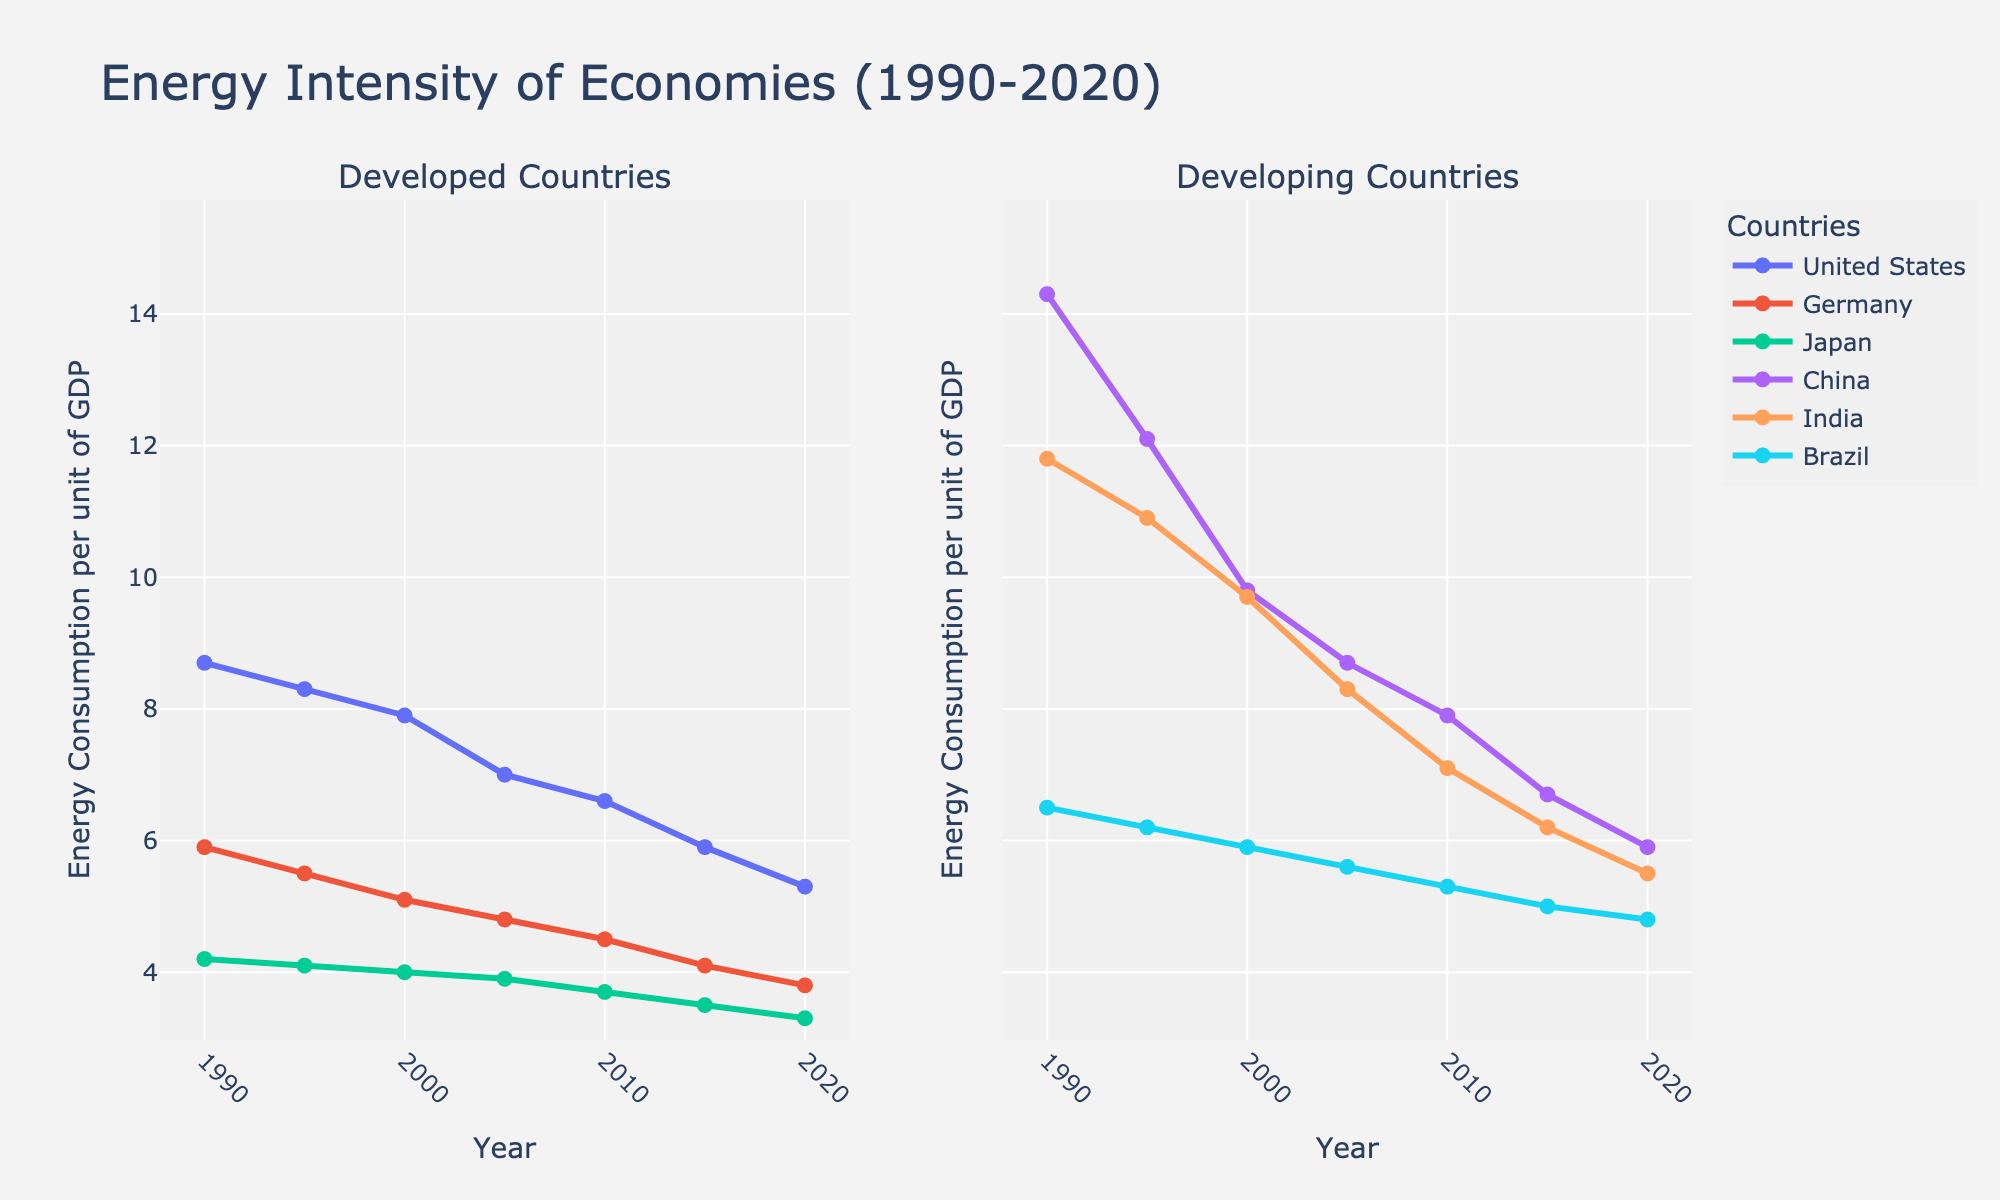What is the general trend of energy intensity in developed countries from 1990 to 2020? The energy intensity in developed countries (United States, Germany, and Japan) shows a decreasing trend from 1990 to 2020, indicating improved energy efficiency over time.
Answer: Decreasing Which developed country had the highest energy intensity in 1990 and by how much was it higher than the country with the lowest energy intensity in the same year? In 1990, the United States had the highest energy intensity among developed countries (8.7), while Japan had the lowest (4.2). The difference is 8.7 - 4.2 = 4.5.
Answer: United States, 4.5 By how much did China's energy intensity decrease from 1990 to 2020? China's energy intensity in 1990 was 14.3 and in 2020 was 5.9. The decrease is 14.3 - 5.9 = 8.4.
Answer: 8.4 Which developing country had the smallest reduction in energy intensity from 1990 to 2020? Brazil had a decrease from 6.5 in 1990 to 4.8 in 2020, which is 6.5 - 4.8 = 1.7, the smallest decrease among the developing countries.
Answer: Brazil How did the energy intensity of India compare to that of Germany in the year 2020? In 2020, India's energy intensity was 5.5 and Germany's was 3.8. India had a higher energy intensity by 5.5 - 3.8 = 1.7.
Answer: Higher by 1.7 What is the average energy intensity for Japan from 1990 to 2020? The average is calculated by summing the energy intensities for Japan (4.2 + 4.1 + 4.0 + 3.9 + 3.7 + 3.5 + 3.3) and then dividing by the number of years: (4.2 + 4.1 + 4.0 + 3.9 + 3.7 + 3.5 + 3.3) / 7 = 3.81.
Answer: 3.81 In which year did the United States see the largest drop in energy intensity compared to the previous recorded year? Comparing the falls: 1990-1995: 0.4, 1995-2000: 0.4, 2000-2005: 0.9, 2005-2010: 0.4, 2010-2015: 0.7, 2015-2020: 0.6. The largest drop is from 2000 to 2005 (0.9).
Answer: 2000-2005 From the graph, what can be inferred about the energy efficiency improvement in developing countries compared to developed countries between 1990 to 2020? Developing countries (China, India, Brazil) show a significant reduction in energy intensity, indicating notable improvements in energy efficiency. However, developed countries also improved steadily, suggesting ongoing efforts in energy efficiency.
Answer: Significant reduction in both Which country shows the most consistent decrease in energy intensity over the years? Germany exhibits a consistent decrease in energy intensity, with a steady decline in the plotted data from 5.9 in 1990 to 3.8 in 2020.
Answer: Germany 